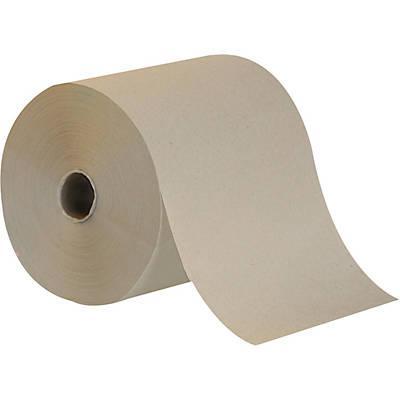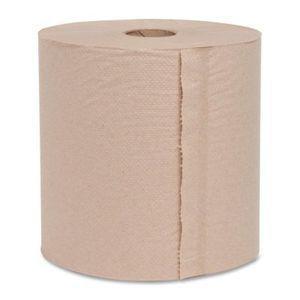The first image is the image on the left, the second image is the image on the right. Analyze the images presented: Is the assertion "The roll of paper in the image on the left is partially unrolled" valid? Answer yes or no. Yes. The first image is the image on the left, the second image is the image on the right. For the images displayed, is the sentence "No paper towel rolls have sheets unfurled." factually correct? Answer yes or no. No. 